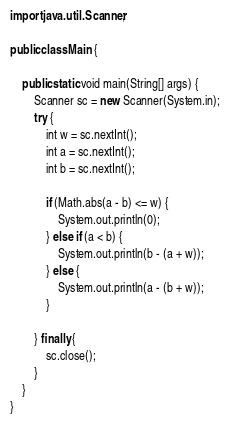<code> <loc_0><loc_0><loc_500><loc_500><_Java_>import java.util.Scanner;

public class Main {

	public static void main(String[] args) {
		Scanner sc = new Scanner(System.in);
		try {
			int w = sc.nextInt();
			int a = sc.nextInt();
			int b = sc.nextInt();

			if (Math.abs(a - b) <= w) {
				System.out.println(0);
			} else if (a < b) {
				System.out.println(b - (a + w));
			} else {
				System.out.println(a - (b + w));
			}

		} finally {
			sc.close();
		}
	}
}</code> 